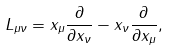Convert formula to latex. <formula><loc_0><loc_0><loc_500><loc_500>L _ { \mu \nu } & = x _ { \mu } \frac { \partial } { \partial x _ { \nu } } - x _ { \nu } \frac { \partial } { \partial x _ { \mu } } ,</formula> 